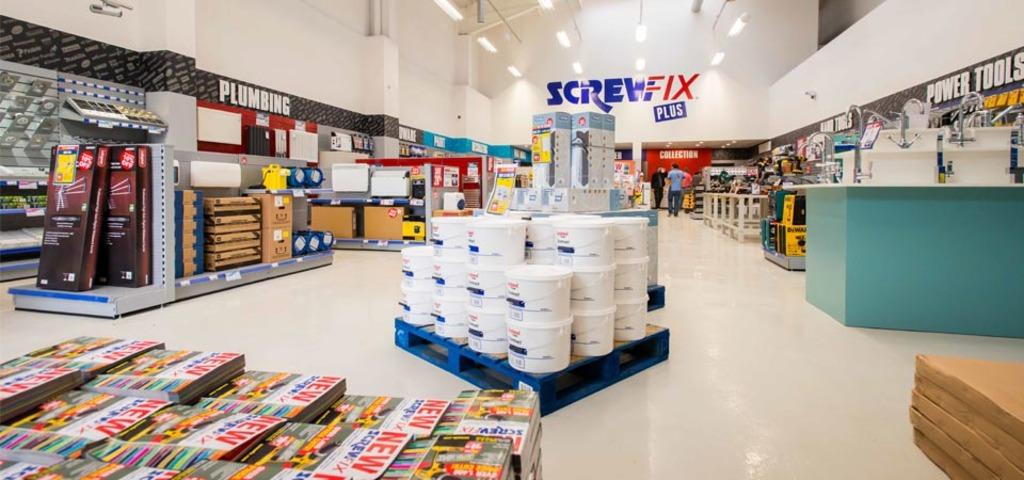<image>
Describe the image concisely. A Screw Fix Plus store is filled with supplies. 